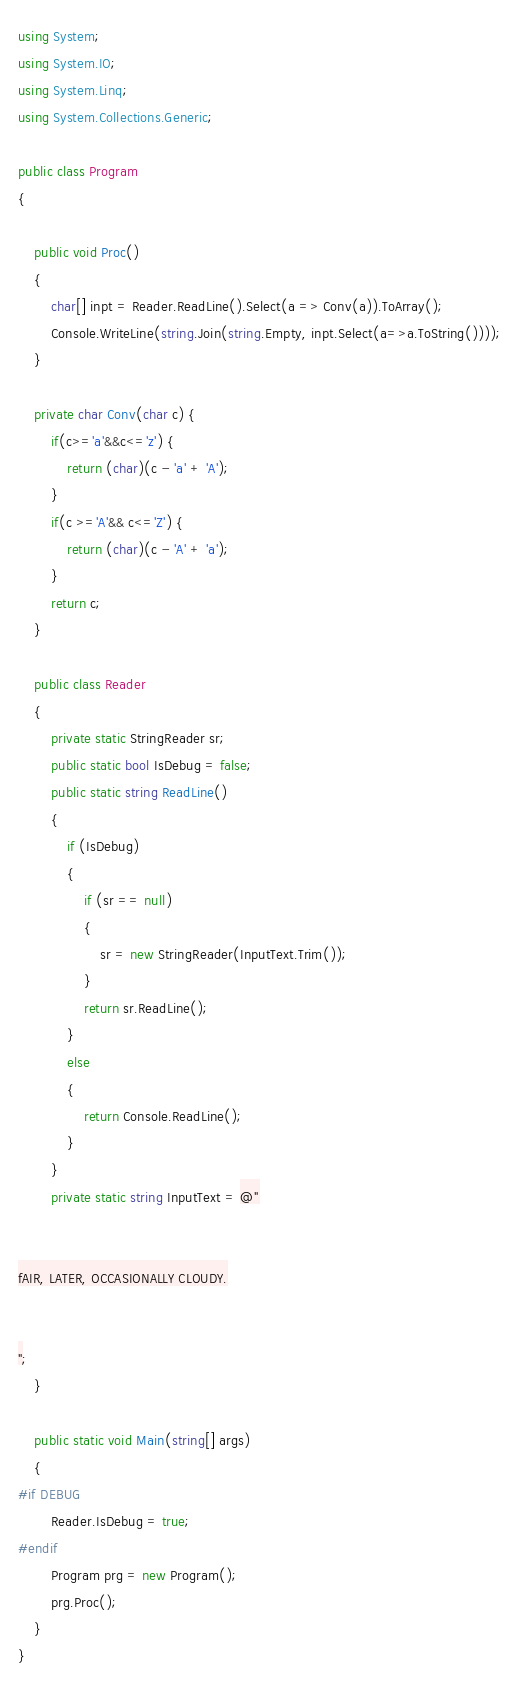<code> <loc_0><loc_0><loc_500><loc_500><_C#_>using System;
using System.IO;
using System.Linq;
using System.Collections.Generic;

public class Program
{

    public void Proc()
    {
        char[] inpt = Reader.ReadLine().Select(a => Conv(a)).ToArray();
        Console.WriteLine(string.Join(string.Empty, inpt.Select(a=>a.ToString())));
    }

    private char Conv(char c) {
        if(c>='a'&&c<='z') {
            return (char)(c - 'a' + 'A');
        }
        if(c >='A'&& c<='Z') {
            return (char)(c - 'A' + 'a');
        }
        return c;
    }

    public class Reader
	{
		private static StringReader sr;
		public static bool IsDebug = false;
		public static string ReadLine()
		{
			if (IsDebug)
			{
				if (sr == null)
				{
					sr = new StringReader(InputText.Trim());
				}
				return sr.ReadLine();
			}
			else
			{
				return Console.ReadLine();
			}
		}
		private static string InputText = @"


fAIR, LATER, OCCASIONALLY CLOUDY.


";
	}

	public static void Main(string[] args)
	{
#if DEBUG
		Reader.IsDebug = true;
#endif
		Program prg = new Program();
		prg.Proc();
	}
}</code> 